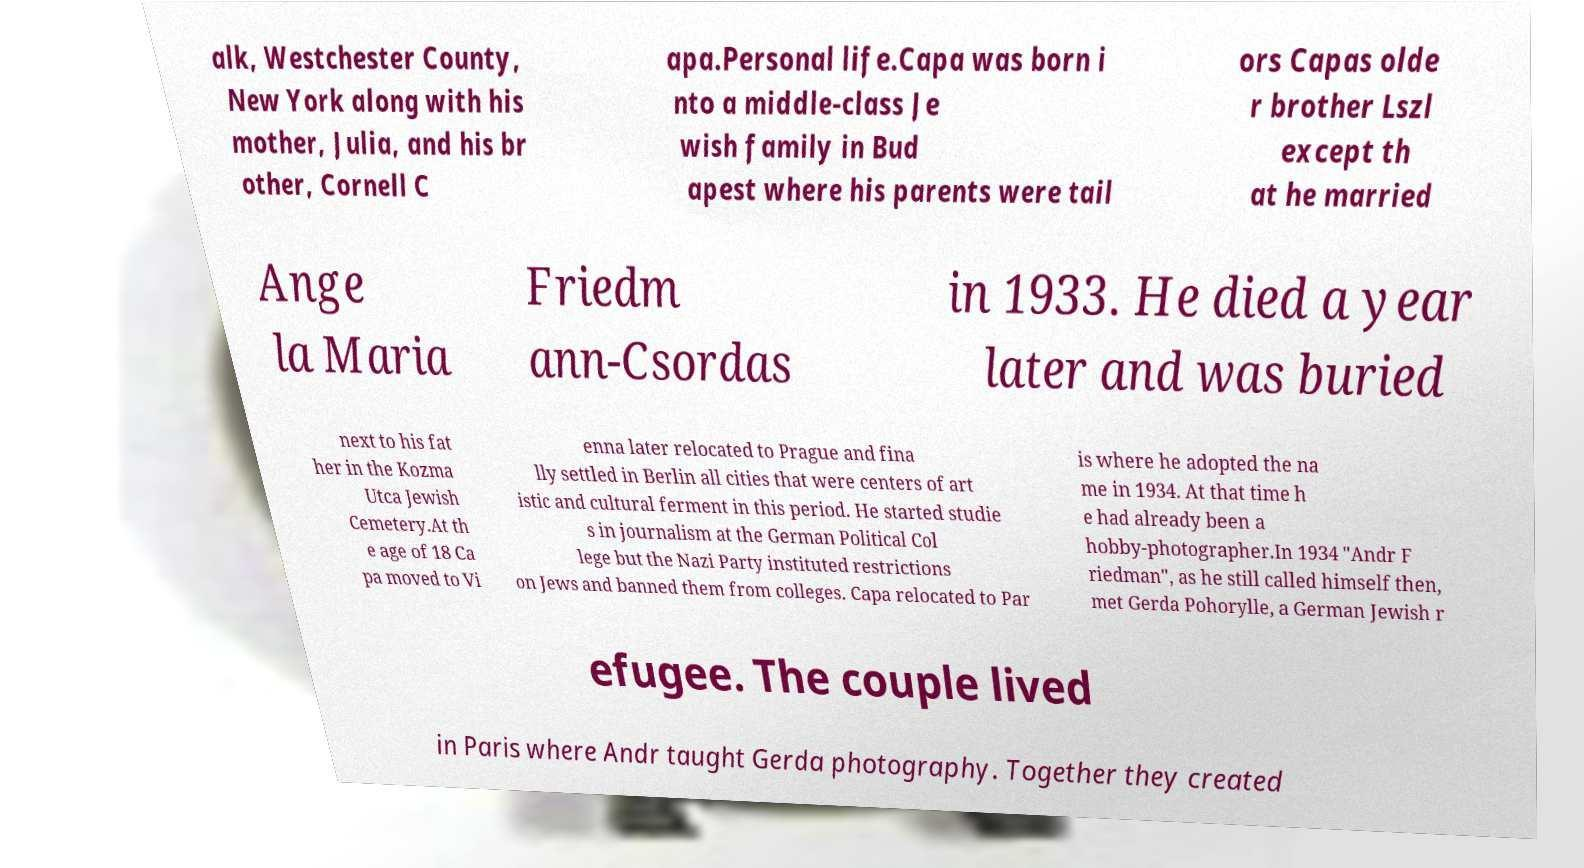Can you read and provide the text displayed in the image?This photo seems to have some interesting text. Can you extract and type it out for me? alk, Westchester County, New York along with his mother, Julia, and his br other, Cornell C apa.Personal life.Capa was born i nto a middle-class Je wish family in Bud apest where his parents were tail ors Capas olde r brother Lszl except th at he married Ange la Maria Friedm ann-Csordas in 1933. He died a year later and was buried next to his fat her in the Kozma Utca Jewish Cemetery.At th e age of 18 Ca pa moved to Vi enna later relocated to Prague and fina lly settled in Berlin all cities that were centers of art istic and cultural ferment in this period. He started studie s in journalism at the German Political Col lege but the Nazi Party instituted restrictions on Jews and banned them from colleges. Capa relocated to Par is where he adopted the na me in 1934. At that time h e had already been a hobby-photographer.In 1934 "Andr F riedman", as he still called himself then, met Gerda Pohorylle, a German Jewish r efugee. The couple lived in Paris where Andr taught Gerda photography. Together they created 